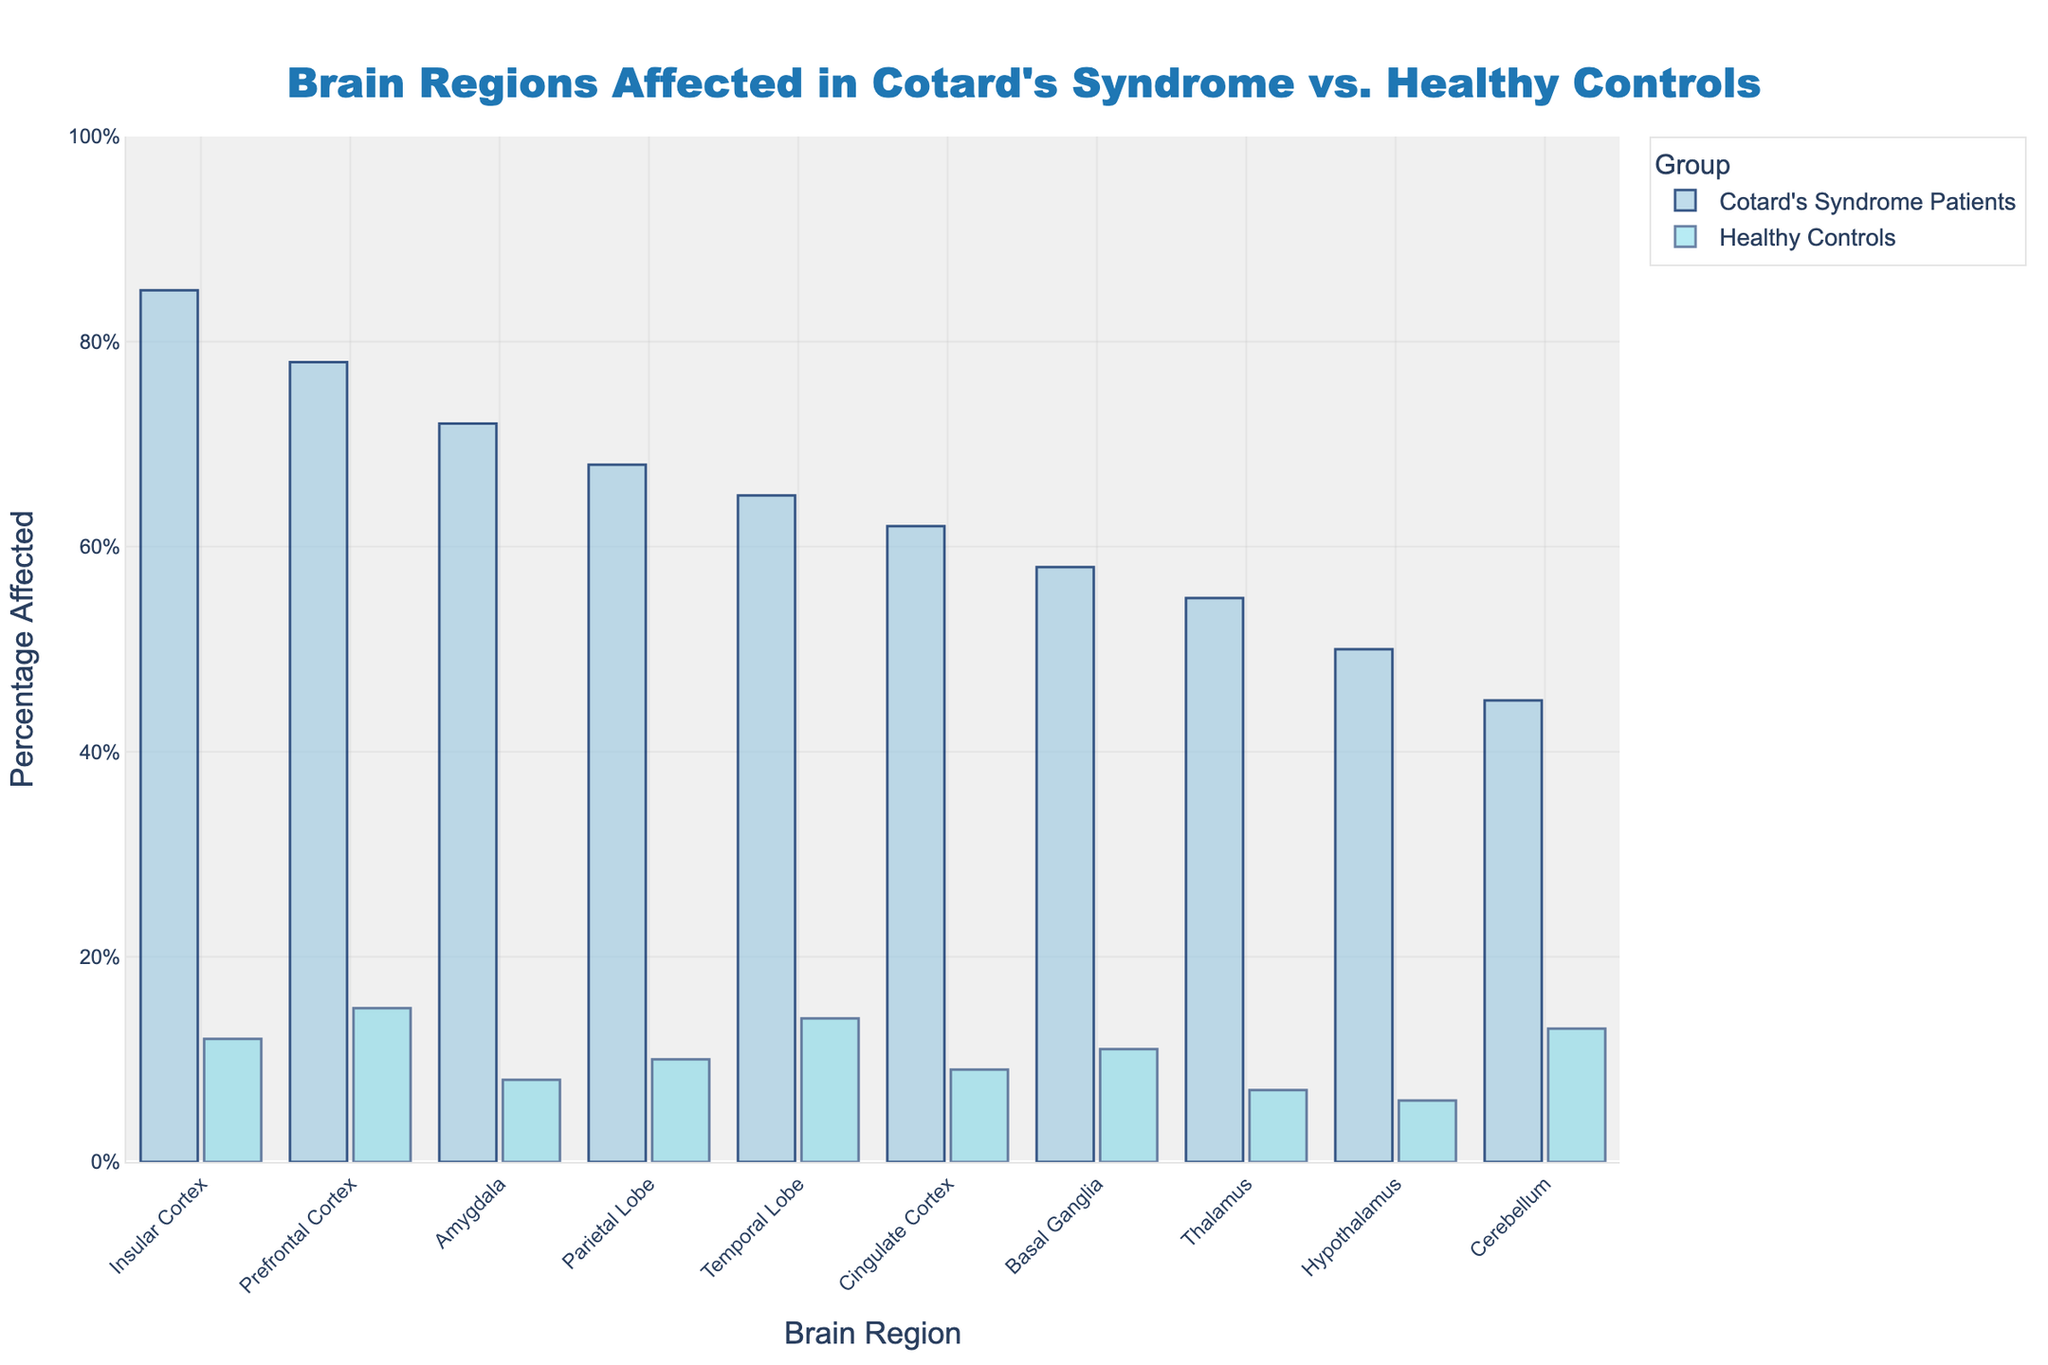Which brain region is most affected in Cotard's syndrome patients? Referring to the height of the bars in the plot, the Insular Cortex has the highest bar among Cotard's Syndrome Patients, indicating it's the most affected region.
Answer: Insular Cortex Which brain region has the smallest difference in percentage affected between Cotard's syndrome patients and healthy controls? Calculating the differences: Insular Cortex (73%), Prefrontal Cortex (63%), Amygdala (64%), Parietal Lobe (58%), Temporal Lobe (51%), Cingulate Cortex (53%), Basal Ganglia (47%), Thalamus (48%), Hypothalamus (44%), Cerebellum (32%). The smallest difference is in the Cerebellum with 32%.
Answer: Cerebellum How much higher is the percentage affected in the Prefrontal Cortex of Cotard's syndrome patients compared to healthy controls? The affected percentage in Cotard's syndrome patients is 78% and in healthy controls is 15%. Subtracting the two gives 78% - 15% = 63%.
Answer: 63% Which brain region has the highest percentage affected in healthy controls? Referring to the height of the bars for healthy controls, the Insular Cortex has the highest percentage affected at 12%.
Answer: Insular Cortex Are there any brain regions where less than 50% of Cotard's syndrome patients are affected? Referring to the height of the bars for Cotard's syndrome patients, the only region with less than 50% affected is the Cerebellum at 45%.
Answer: Cerebellum Which brain region has the biggest disparity in percentage affected between Cotard's syndrome patients and healthy controls? The differences calculated previously were: Insular Cortex (73%), Prefrontal Cortex (63%), Amygdala (64%), Parietal Lobe (58%), Temporal Lobe (51%), Cingulate Cortex (53%), Basal Ganglia (47%), Thalamus (48%), Hypothalamus (44%), Cerebellum (32%). The largest disparity is in the Insular Cortex with 73%.
Answer: Insular Cortex Of the brain regions with more than 60% affected in Cotard’s syndrome patients, which also has more than 10% affected in healthy controls? Brain regions in Cotard's syndrome patients with more than 60% affected: Insular Cortex, Prefrontal Cortex, Amygdala, Parietal Lobe, Temporal Lobe, Cingulate Cortex. Among these, Insular Cortex (12%), Prefrontal Cortex (15%), Temporal Lobe (14%), and Cerebellum (13%) have more than 10% affected in healthy controls.
Answer: Insular Cortex, Prefrontal Cortex, Temporal Lobe Which brain regions are affected in more than 50% of Cotard's syndrome patients but less than 10% of healthy controls? Brain regions in Cotard's syndrome patients with more than 50% affected: Insular Cortex, Prefrontal Cortex, Amygdala, Parietal Lobe, Temporal Lobe, Cingulate Cortex, Basal Ganglia, Thalamus, Hypothalamus. Among these, Amygdala (8%), Cingulate Cortex (9%), Thalamus (7%), and Hypothalamus (6%) have less than 10% affected in healthy controls.
Answer: Amygdala, Cingulate Cortex, Thalamus, Hypothalamus What is the average percentage affected across all brain regions for Cotard’s syndrome patients? Add up the percentages for Cotard’s syndrome patients (85% + 78% + 72% + 68% + 65% + 62% + 58% + 55% + 50% + 45%) = 638. Divide this sum by the number of brain regions (10) to get the average: 638/10 = 63.8%.
Answer: 63.8% 